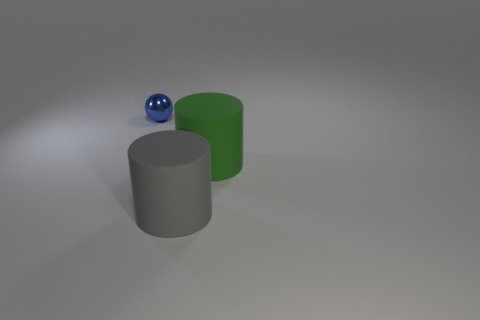Add 1 large gray rubber cylinders. How many objects exist? 4 Subtract all cylinders. How many objects are left? 1 Add 3 large gray cylinders. How many large gray cylinders are left? 4 Add 1 large green matte cylinders. How many large green matte cylinders exist? 2 Subtract 0 cyan cylinders. How many objects are left? 3 Subtract all tiny cyan balls. Subtract all big cylinders. How many objects are left? 1 